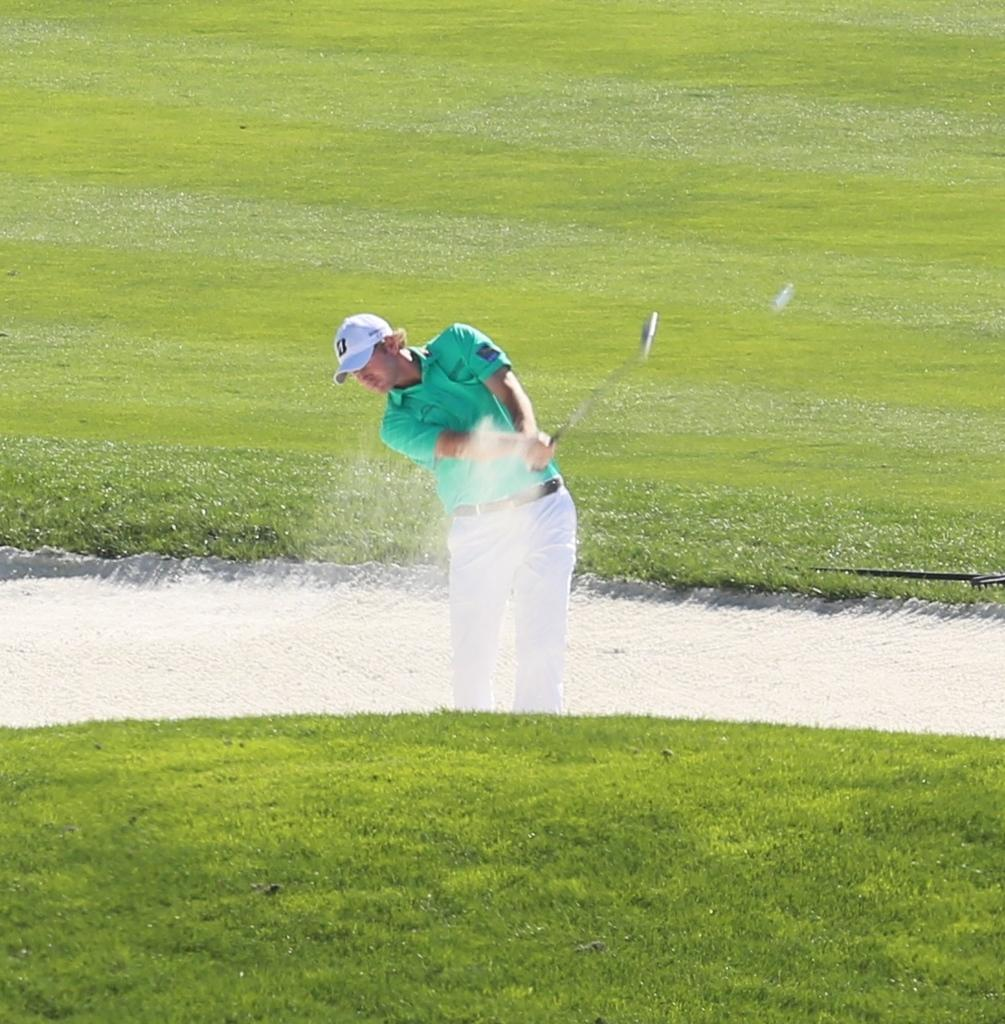Who is the person in the image? There is a man in the image. What is the man doing in the image? The man is playing golf. What type of terrain is visible at the bottom of the image? There is green grass at the bottom of the image. What is present in the middle of the image? There is water in the middle of the image. What can be seen in the background of the image? There is a ground with green grass in the background of the image. Where is the faucet located in the image? There is no faucet present in the image. What impulse does the man have while playing golf in the image? The provided facts do not give information about the man's impulses or emotions while playing golf, so it cannot be determined from the image. 